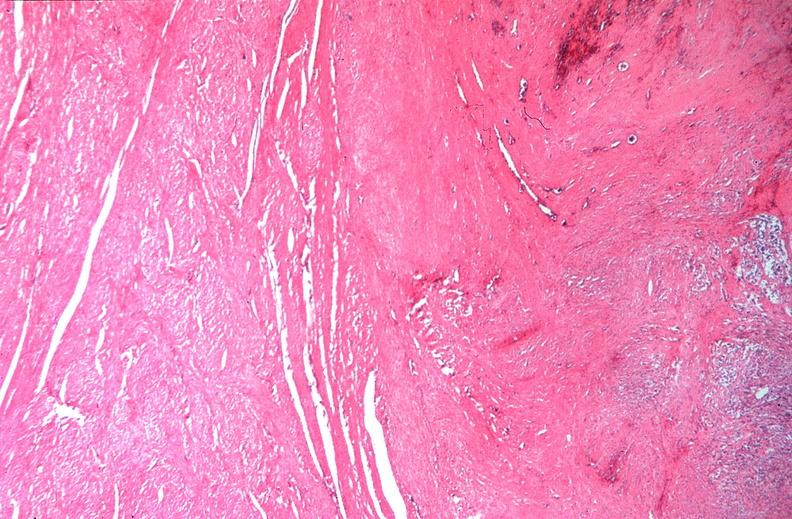where is this from?
Answer the question using a single word or phrase. Female reproductive system 